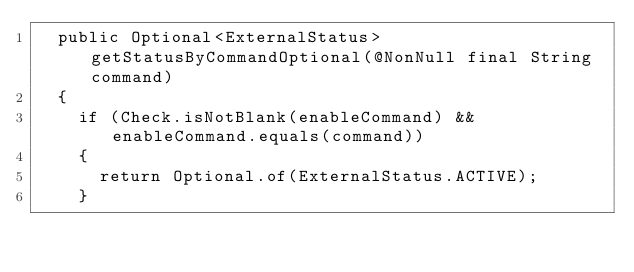<code> <loc_0><loc_0><loc_500><loc_500><_Java_>	public Optional<ExternalStatus> getStatusByCommandOptional(@NonNull final String command)
	{
		if (Check.isNotBlank(enableCommand) && enableCommand.equals(command))
		{
			return Optional.of(ExternalStatus.ACTIVE);
		}
</code> 